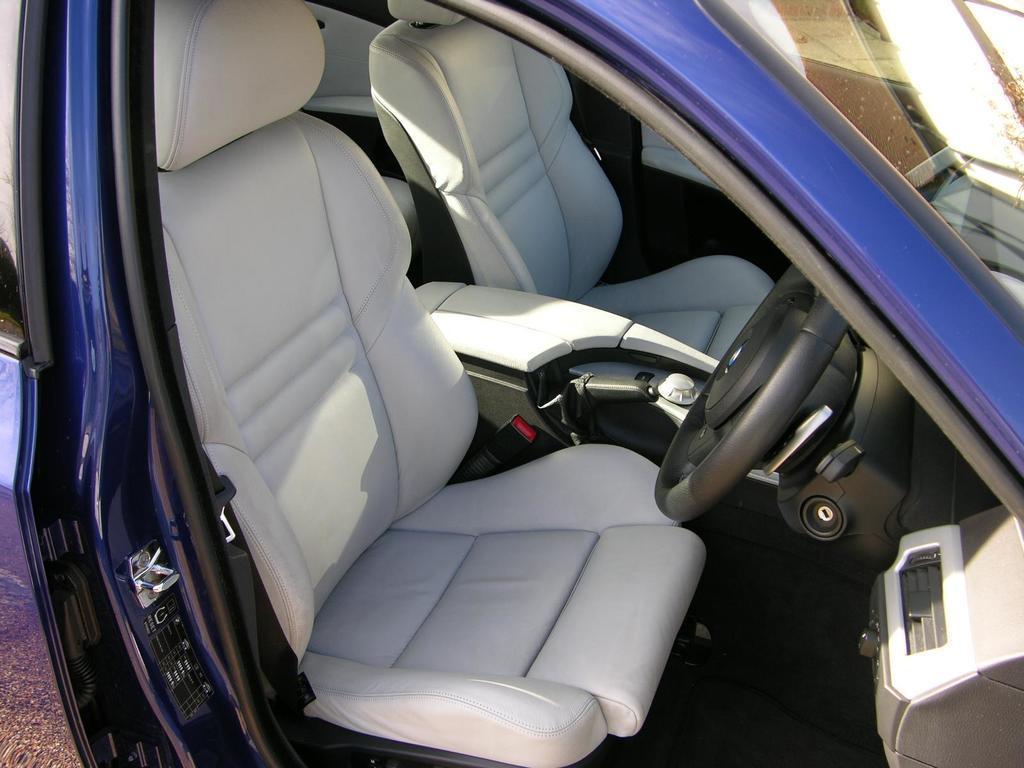Can you describe this image briefly? In this image in the center there is a car which is blue in colour and there are seats inside the car and this is a steering. 